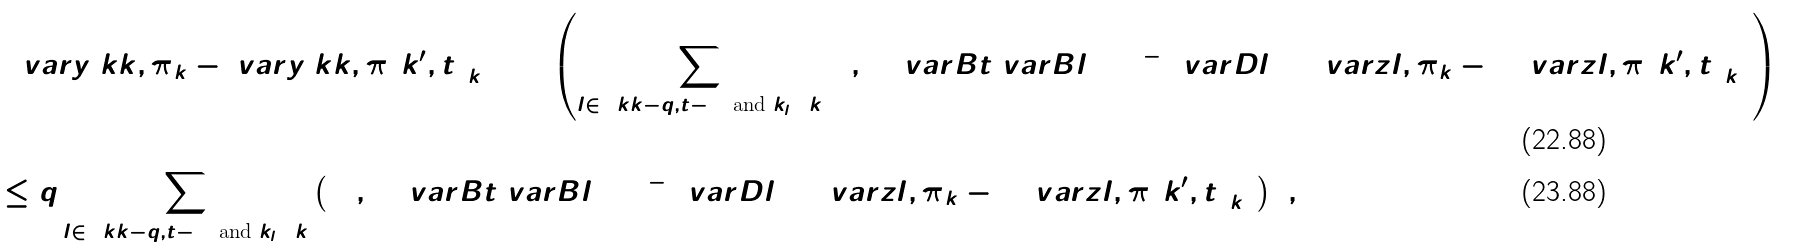Convert formula to latex. <formula><loc_0><loc_0><loc_500><loc_500>& \left ( \ v a r { y } { \ k k , \pi } _ { k } - \ v a r { y } { \ k k , \pi ( k ^ { \prime } , t ) } _ { k } \right ) ^ { 2 } = \left ( \sum _ { l \in [ \ k k - q , t - 1 ] \text { and } k _ { l } = k } ( 1 , 0 ) \ v a r { B } { t } { \ v a r { B } { l + 1 } } ^ { - 1 } \ v a r { D } { l } \left ( \Delta \ v a r { z } { l , \pi } _ { k } - \Delta \ v a r { z } { l , \pi ( k ^ { \prime } , t ) } _ { k } \right ) \right ) ^ { 2 } \\ & \leq q \sum _ { l \in [ \ k k - q , t - 1 ] \text { and } k _ { l } = k } \left ( ( 1 , 0 ) \ v a r { B } { t } { \ v a r { B } { l + 1 } } ^ { - 1 } \ v a r { D } { l } \left ( \Delta \ v a r { z } { l , \pi } _ { k } - \Delta \ v a r { z } { l , \pi ( k ^ { \prime } , t ) } _ { k } \right ) \right ) ^ { 2 } ,</formula> 